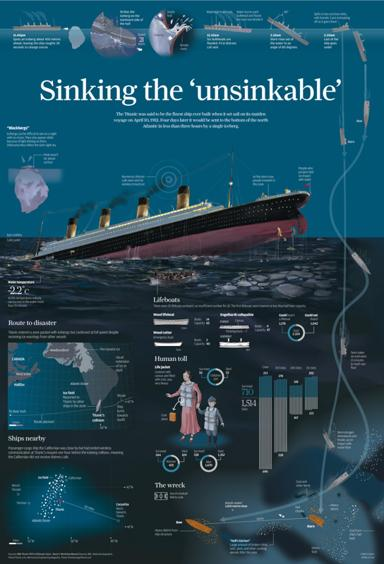How does the infographic illustrate the human toll of the Titanic's sinking? The infographic provides a detailed breakdown of the human toll, showing statistics for survivors and casualties among passengers and crew. It features visuals like bar charts and diagrams to represent the data clearly, segmented by class and crew. 